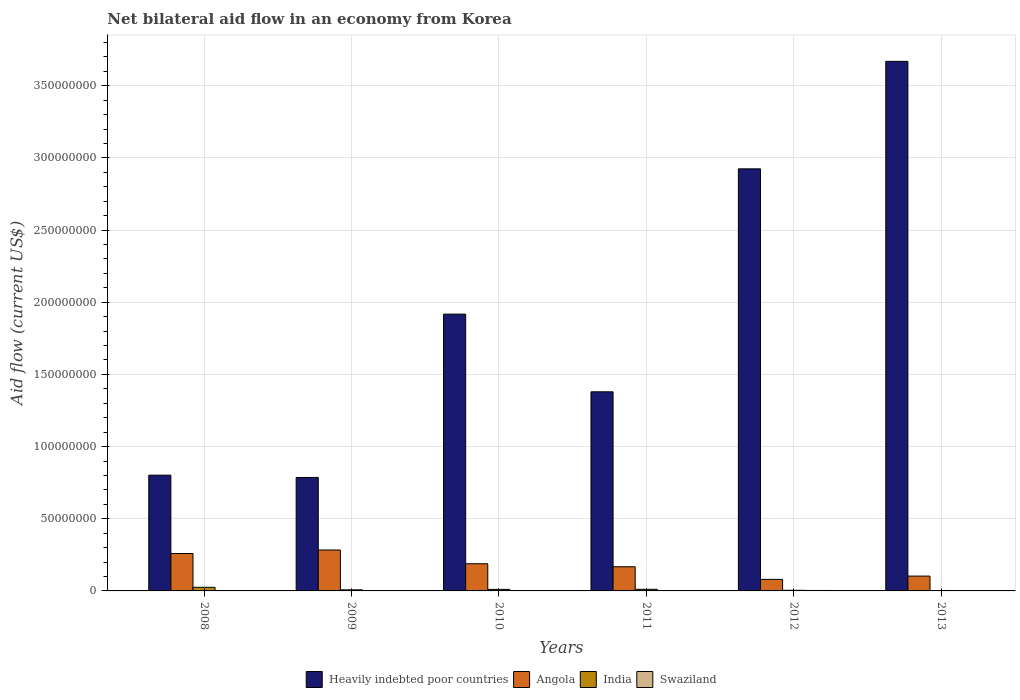Are the number of bars on each tick of the X-axis equal?
Offer a very short reply. Yes. How many bars are there on the 2nd tick from the left?
Make the answer very short. 4. Across all years, what is the maximum net bilateral aid flow in Heavily indebted poor countries?
Keep it short and to the point. 3.67e+08. Across all years, what is the minimum net bilateral aid flow in Heavily indebted poor countries?
Your response must be concise. 7.86e+07. In which year was the net bilateral aid flow in Heavily indebted poor countries maximum?
Your answer should be compact. 2013. What is the total net bilateral aid flow in Swaziland in the graph?
Your answer should be compact. 9.90e+05. What is the difference between the net bilateral aid flow in Angola in 2011 and that in 2013?
Your answer should be compact. 6.47e+06. What is the difference between the net bilateral aid flow in Heavily indebted poor countries in 2009 and the net bilateral aid flow in India in 2012?
Make the answer very short. 7.82e+07. What is the average net bilateral aid flow in Angola per year?
Give a very brief answer. 1.80e+07. In the year 2008, what is the difference between the net bilateral aid flow in Swaziland and net bilateral aid flow in Heavily indebted poor countries?
Your response must be concise. -8.00e+07. In how many years, is the net bilateral aid flow in Heavily indebted poor countries greater than 30000000 US$?
Your response must be concise. 6. What is the ratio of the net bilateral aid flow in Heavily indebted poor countries in 2008 to that in 2009?
Keep it short and to the point. 1.02. Is the difference between the net bilateral aid flow in Swaziland in 2008 and 2009 greater than the difference between the net bilateral aid flow in Heavily indebted poor countries in 2008 and 2009?
Give a very brief answer. No. What is the difference between the highest and the lowest net bilateral aid flow in India?
Ensure brevity in your answer.  2.20e+06. In how many years, is the net bilateral aid flow in Heavily indebted poor countries greater than the average net bilateral aid flow in Heavily indebted poor countries taken over all years?
Your answer should be compact. 3. Is the sum of the net bilateral aid flow in India in 2010 and 2012 greater than the maximum net bilateral aid flow in Swaziland across all years?
Make the answer very short. Yes. What does the 2nd bar from the left in 2008 represents?
Provide a succinct answer. Angola. How many bars are there?
Ensure brevity in your answer.  24. What is the difference between two consecutive major ticks on the Y-axis?
Keep it short and to the point. 5.00e+07. Are the values on the major ticks of Y-axis written in scientific E-notation?
Your answer should be very brief. No. Does the graph contain any zero values?
Offer a terse response. No. Does the graph contain grids?
Your answer should be very brief. Yes. How are the legend labels stacked?
Your answer should be compact. Horizontal. What is the title of the graph?
Make the answer very short. Net bilateral aid flow in an economy from Korea. What is the label or title of the X-axis?
Give a very brief answer. Years. What is the label or title of the Y-axis?
Your answer should be very brief. Aid flow (current US$). What is the Aid flow (current US$) of Heavily indebted poor countries in 2008?
Provide a succinct answer. 8.02e+07. What is the Aid flow (current US$) in Angola in 2008?
Keep it short and to the point. 2.59e+07. What is the Aid flow (current US$) of India in 2008?
Offer a very short reply. 2.50e+06. What is the Aid flow (current US$) of Swaziland in 2008?
Your answer should be very brief. 1.80e+05. What is the Aid flow (current US$) of Heavily indebted poor countries in 2009?
Provide a succinct answer. 7.86e+07. What is the Aid flow (current US$) in Angola in 2009?
Keep it short and to the point. 2.83e+07. What is the Aid flow (current US$) of India in 2009?
Offer a very short reply. 7.50e+05. What is the Aid flow (current US$) in Swaziland in 2009?
Make the answer very short. 1.00e+05. What is the Aid flow (current US$) in Heavily indebted poor countries in 2010?
Your response must be concise. 1.92e+08. What is the Aid flow (current US$) of Angola in 2010?
Your answer should be very brief. 1.88e+07. What is the Aid flow (current US$) in India in 2010?
Provide a succinct answer. 1.07e+06. What is the Aid flow (current US$) in Heavily indebted poor countries in 2011?
Offer a terse response. 1.38e+08. What is the Aid flow (current US$) in Angola in 2011?
Make the answer very short. 1.68e+07. What is the Aid flow (current US$) in India in 2011?
Give a very brief answer. 1.13e+06. What is the Aid flow (current US$) in Swaziland in 2011?
Keep it short and to the point. 1.70e+05. What is the Aid flow (current US$) in Heavily indebted poor countries in 2012?
Offer a very short reply. 2.92e+08. What is the Aid flow (current US$) in Angola in 2012?
Ensure brevity in your answer.  7.98e+06. What is the Aid flow (current US$) of Heavily indebted poor countries in 2013?
Your response must be concise. 3.67e+08. What is the Aid flow (current US$) in Angola in 2013?
Your response must be concise. 1.03e+07. What is the Aid flow (current US$) of India in 2013?
Offer a very short reply. 3.00e+05. Across all years, what is the maximum Aid flow (current US$) in Heavily indebted poor countries?
Your answer should be very brief. 3.67e+08. Across all years, what is the maximum Aid flow (current US$) in Angola?
Your answer should be compact. 2.83e+07. Across all years, what is the maximum Aid flow (current US$) in India?
Provide a succinct answer. 2.50e+06. Across all years, what is the maximum Aid flow (current US$) in Swaziland?
Your answer should be compact. 3.20e+05. Across all years, what is the minimum Aid flow (current US$) in Heavily indebted poor countries?
Your answer should be compact. 7.86e+07. Across all years, what is the minimum Aid flow (current US$) of Angola?
Offer a very short reply. 7.98e+06. Across all years, what is the minimum Aid flow (current US$) of India?
Make the answer very short. 3.00e+05. Across all years, what is the minimum Aid flow (current US$) in Swaziland?
Give a very brief answer. 4.00e+04. What is the total Aid flow (current US$) of Heavily indebted poor countries in the graph?
Your answer should be compact. 1.15e+09. What is the total Aid flow (current US$) of Angola in the graph?
Offer a terse response. 1.08e+08. What is the total Aid flow (current US$) in India in the graph?
Provide a short and direct response. 6.18e+06. What is the total Aid flow (current US$) of Swaziland in the graph?
Offer a very short reply. 9.90e+05. What is the difference between the Aid flow (current US$) of Heavily indebted poor countries in 2008 and that in 2009?
Keep it short and to the point. 1.59e+06. What is the difference between the Aid flow (current US$) of Angola in 2008 and that in 2009?
Offer a very short reply. -2.42e+06. What is the difference between the Aid flow (current US$) in India in 2008 and that in 2009?
Provide a short and direct response. 1.75e+06. What is the difference between the Aid flow (current US$) in Swaziland in 2008 and that in 2009?
Your answer should be very brief. 8.00e+04. What is the difference between the Aid flow (current US$) in Heavily indebted poor countries in 2008 and that in 2010?
Keep it short and to the point. -1.12e+08. What is the difference between the Aid flow (current US$) in Angola in 2008 and that in 2010?
Keep it short and to the point. 7.09e+06. What is the difference between the Aid flow (current US$) of India in 2008 and that in 2010?
Offer a very short reply. 1.43e+06. What is the difference between the Aid flow (current US$) of Swaziland in 2008 and that in 2010?
Your response must be concise. 0. What is the difference between the Aid flow (current US$) of Heavily indebted poor countries in 2008 and that in 2011?
Your answer should be compact. -5.78e+07. What is the difference between the Aid flow (current US$) in Angola in 2008 and that in 2011?
Make the answer very short. 9.17e+06. What is the difference between the Aid flow (current US$) of India in 2008 and that in 2011?
Your response must be concise. 1.37e+06. What is the difference between the Aid flow (current US$) in Swaziland in 2008 and that in 2011?
Offer a very short reply. 10000. What is the difference between the Aid flow (current US$) of Heavily indebted poor countries in 2008 and that in 2012?
Provide a succinct answer. -2.12e+08. What is the difference between the Aid flow (current US$) of Angola in 2008 and that in 2012?
Your answer should be compact. 1.79e+07. What is the difference between the Aid flow (current US$) in India in 2008 and that in 2012?
Give a very brief answer. 2.07e+06. What is the difference between the Aid flow (current US$) of Swaziland in 2008 and that in 2012?
Provide a short and direct response. -1.40e+05. What is the difference between the Aid flow (current US$) in Heavily indebted poor countries in 2008 and that in 2013?
Offer a very short reply. -2.87e+08. What is the difference between the Aid flow (current US$) of Angola in 2008 and that in 2013?
Make the answer very short. 1.56e+07. What is the difference between the Aid flow (current US$) in India in 2008 and that in 2013?
Keep it short and to the point. 2.20e+06. What is the difference between the Aid flow (current US$) of Heavily indebted poor countries in 2009 and that in 2010?
Make the answer very short. -1.13e+08. What is the difference between the Aid flow (current US$) of Angola in 2009 and that in 2010?
Keep it short and to the point. 9.51e+06. What is the difference between the Aid flow (current US$) of India in 2009 and that in 2010?
Provide a succinct answer. -3.20e+05. What is the difference between the Aid flow (current US$) of Heavily indebted poor countries in 2009 and that in 2011?
Your answer should be compact. -5.93e+07. What is the difference between the Aid flow (current US$) of Angola in 2009 and that in 2011?
Offer a very short reply. 1.16e+07. What is the difference between the Aid flow (current US$) in India in 2009 and that in 2011?
Make the answer very short. -3.80e+05. What is the difference between the Aid flow (current US$) in Heavily indebted poor countries in 2009 and that in 2012?
Your answer should be very brief. -2.14e+08. What is the difference between the Aid flow (current US$) in Angola in 2009 and that in 2012?
Keep it short and to the point. 2.04e+07. What is the difference between the Aid flow (current US$) of India in 2009 and that in 2012?
Ensure brevity in your answer.  3.20e+05. What is the difference between the Aid flow (current US$) of Heavily indebted poor countries in 2009 and that in 2013?
Your answer should be compact. -2.88e+08. What is the difference between the Aid flow (current US$) in Angola in 2009 and that in 2013?
Offer a very short reply. 1.81e+07. What is the difference between the Aid flow (current US$) in Swaziland in 2009 and that in 2013?
Ensure brevity in your answer.  6.00e+04. What is the difference between the Aid flow (current US$) in Heavily indebted poor countries in 2010 and that in 2011?
Offer a very short reply. 5.38e+07. What is the difference between the Aid flow (current US$) of Angola in 2010 and that in 2011?
Give a very brief answer. 2.08e+06. What is the difference between the Aid flow (current US$) in India in 2010 and that in 2011?
Make the answer very short. -6.00e+04. What is the difference between the Aid flow (current US$) of Swaziland in 2010 and that in 2011?
Provide a succinct answer. 10000. What is the difference between the Aid flow (current US$) of Heavily indebted poor countries in 2010 and that in 2012?
Ensure brevity in your answer.  -1.01e+08. What is the difference between the Aid flow (current US$) in Angola in 2010 and that in 2012?
Your answer should be compact. 1.08e+07. What is the difference between the Aid flow (current US$) of India in 2010 and that in 2012?
Give a very brief answer. 6.40e+05. What is the difference between the Aid flow (current US$) of Swaziland in 2010 and that in 2012?
Offer a very short reply. -1.40e+05. What is the difference between the Aid flow (current US$) of Heavily indebted poor countries in 2010 and that in 2013?
Your answer should be very brief. -1.75e+08. What is the difference between the Aid flow (current US$) of Angola in 2010 and that in 2013?
Your answer should be very brief. 8.55e+06. What is the difference between the Aid flow (current US$) in India in 2010 and that in 2013?
Provide a short and direct response. 7.70e+05. What is the difference between the Aid flow (current US$) of Swaziland in 2010 and that in 2013?
Offer a terse response. 1.40e+05. What is the difference between the Aid flow (current US$) in Heavily indebted poor countries in 2011 and that in 2012?
Offer a terse response. -1.54e+08. What is the difference between the Aid flow (current US$) in Angola in 2011 and that in 2012?
Your response must be concise. 8.77e+06. What is the difference between the Aid flow (current US$) of Swaziland in 2011 and that in 2012?
Make the answer very short. -1.50e+05. What is the difference between the Aid flow (current US$) of Heavily indebted poor countries in 2011 and that in 2013?
Your answer should be very brief. -2.29e+08. What is the difference between the Aid flow (current US$) of Angola in 2011 and that in 2013?
Offer a terse response. 6.47e+06. What is the difference between the Aid flow (current US$) in India in 2011 and that in 2013?
Offer a terse response. 8.30e+05. What is the difference between the Aid flow (current US$) of Swaziland in 2011 and that in 2013?
Provide a succinct answer. 1.30e+05. What is the difference between the Aid flow (current US$) in Heavily indebted poor countries in 2012 and that in 2013?
Offer a very short reply. -7.45e+07. What is the difference between the Aid flow (current US$) in Angola in 2012 and that in 2013?
Offer a terse response. -2.30e+06. What is the difference between the Aid flow (current US$) of Heavily indebted poor countries in 2008 and the Aid flow (current US$) of Angola in 2009?
Offer a terse response. 5.19e+07. What is the difference between the Aid flow (current US$) of Heavily indebted poor countries in 2008 and the Aid flow (current US$) of India in 2009?
Your answer should be very brief. 7.94e+07. What is the difference between the Aid flow (current US$) in Heavily indebted poor countries in 2008 and the Aid flow (current US$) in Swaziland in 2009?
Your answer should be compact. 8.01e+07. What is the difference between the Aid flow (current US$) of Angola in 2008 and the Aid flow (current US$) of India in 2009?
Offer a very short reply. 2.52e+07. What is the difference between the Aid flow (current US$) of Angola in 2008 and the Aid flow (current US$) of Swaziland in 2009?
Offer a terse response. 2.58e+07. What is the difference between the Aid flow (current US$) in India in 2008 and the Aid flow (current US$) in Swaziland in 2009?
Offer a terse response. 2.40e+06. What is the difference between the Aid flow (current US$) in Heavily indebted poor countries in 2008 and the Aid flow (current US$) in Angola in 2010?
Provide a short and direct response. 6.14e+07. What is the difference between the Aid flow (current US$) in Heavily indebted poor countries in 2008 and the Aid flow (current US$) in India in 2010?
Your answer should be compact. 7.91e+07. What is the difference between the Aid flow (current US$) in Heavily indebted poor countries in 2008 and the Aid flow (current US$) in Swaziland in 2010?
Make the answer very short. 8.00e+07. What is the difference between the Aid flow (current US$) of Angola in 2008 and the Aid flow (current US$) of India in 2010?
Keep it short and to the point. 2.48e+07. What is the difference between the Aid flow (current US$) in Angola in 2008 and the Aid flow (current US$) in Swaziland in 2010?
Offer a terse response. 2.57e+07. What is the difference between the Aid flow (current US$) in India in 2008 and the Aid flow (current US$) in Swaziland in 2010?
Keep it short and to the point. 2.32e+06. What is the difference between the Aid flow (current US$) in Heavily indebted poor countries in 2008 and the Aid flow (current US$) in Angola in 2011?
Offer a very short reply. 6.34e+07. What is the difference between the Aid flow (current US$) of Heavily indebted poor countries in 2008 and the Aid flow (current US$) of India in 2011?
Provide a succinct answer. 7.91e+07. What is the difference between the Aid flow (current US$) in Heavily indebted poor countries in 2008 and the Aid flow (current US$) in Swaziland in 2011?
Your answer should be compact. 8.00e+07. What is the difference between the Aid flow (current US$) in Angola in 2008 and the Aid flow (current US$) in India in 2011?
Your answer should be compact. 2.48e+07. What is the difference between the Aid flow (current US$) in Angola in 2008 and the Aid flow (current US$) in Swaziland in 2011?
Offer a terse response. 2.58e+07. What is the difference between the Aid flow (current US$) in India in 2008 and the Aid flow (current US$) in Swaziland in 2011?
Keep it short and to the point. 2.33e+06. What is the difference between the Aid flow (current US$) of Heavily indebted poor countries in 2008 and the Aid flow (current US$) of Angola in 2012?
Your response must be concise. 7.22e+07. What is the difference between the Aid flow (current US$) of Heavily indebted poor countries in 2008 and the Aid flow (current US$) of India in 2012?
Give a very brief answer. 7.98e+07. What is the difference between the Aid flow (current US$) in Heavily indebted poor countries in 2008 and the Aid flow (current US$) in Swaziland in 2012?
Your answer should be very brief. 7.99e+07. What is the difference between the Aid flow (current US$) in Angola in 2008 and the Aid flow (current US$) in India in 2012?
Make the answer very short. 2.55e+07. What is the difference between the Aid flow (current US$) in Angola in 2008 and the Aid flow (current US$) in Swaziland in 2012?
Offer a very short reply. 2.56e+07. What is the difference between the Aid flow (current US$) in India in 2008 and the Aid flow (current US$) in Swaziland in 2012?
Offer a very short reply. 2.18e+06. What is the difference between the Aid flow (current US$) in Heavily indebted poor countries in 2008 and the Aid flow (current US$) in Angola in 2013?
Ensure brevity in your answer.  6.99e+07. What is the difference between the Aid flow (current US$) of Heavily indebted poor countries in 2008 and the Aid flow (current US$) of India in 2013?
Your answer should be very brief. 7.99e+07. What is the difference between the Aid flow (current US$) of Heavily indebted poor countries in 2008 and the Aid flow (current US$) of Swaziland in 2013?
Your answer should be very brief. 8.02e+07. What is the difference between the Aid flow (current US$) of Angola in 2008 and the Aid flow (current US$) of India in 2013?
Make the answer very short. 2.56e+07. What is the difference between the Aid flow (current US$) of Angola in 2008 and the Aid flow (current US$) of Swaziland in 2013?
Your answer should be very brief. 2.59e+07. What is the difference between the Aid flow (current US$) of India in 2008 and the Aid flow (current US$) of Swaziland in 2013?
Offer a terse response. 2.46e+06. What is the difference between the Aid flow (current US$) in Heavily indebted poor countries in 2009 and the Aid flow (current US$) in Angola in 2010?
Ensure brevity in your answer.  5.98e+07. What is the difference between the Aid flow (current US$) of Heavily indebted poor countries in 2009 and the Aid flow (current US$) of India in 2010?
Provide a succinct answer. 7.75e+07. What is the difference between the Aid flow (current US$) in Heavily indebted poor countries in 2009 and the Aid flow (current US$) in Swaziland in 2010?
Provide a succinct answer. 7.84e+07. What is the difference between the Aid flow (current US$) of Angola in 2009 and the Aid flow (current US$) of India in 2010?
Offer a terse response. 2.73e+07. What is the difference between the Aid flow (current US$) of Angola in 2009 and the Aid flow (current US$) of Swaziland in 2010?
Provide a short and direct response. 2.82e+07. What is the difference between the Aid flow (current US$) of India in 2009 and the Aid flow (current US$) of Swaziland in 2010?
Provide a succinct answer. 5.70e+05. What is the difference between the Aid flow (current US$) of Heavily indebted poor countries in 2009 and the Aid flow (current US$) of Angola in 2011?
Your answer should be very brief. 6.19e+07. What is the difference between the Aid flow (current US$) of Heavily indebted poor countries in 2009 and the Aid flow (current US$) of India in 2011?
Offer a terse response. 7.75e+07. What is the difference between the Aid flow (current US$) in Heavily indebted poor countries in 2009 and the Aid flow (current US$) in Swaziland in 2011?
Your answer should be compact. 7.84e+07. What is the difference between the Aid flow (current US$) of Angola in 2009 and the Aid flow (current US$) of India in 2011?
Offer a terse response. 2.72e+07. What is the difference between the Aid flow (current US$) of Angola in 2009 and the Aid flow (current US$) of Swaziland in 2011?
Your answer should be very brief. 2.82e+07. What is the difference between the Aid flow (current US$) in India in 2009 and the Aid flow (current US$) in Swaziland in 2011?
Provide a succinct answer. 5.80e+05. What is the difference between the Aid flow (current US$) in Heavily indebted poor countries in 2009 and the Aid flow (current US$) in Angola in 2012?
Your answer should be compact. 7.06e+07. What is the difference between the Aid flow (current US$) in Heavily indebted poor countries in 2009 and the Aid flow (current US$) in India in 2012?
Provide a short and direct response. 7.82e+07. What is the difference between the Aid flow (current US$) of Heavily indebted poor countries in 2009 and the Aid flow (current US$) of Swaziland in 2012?
Your answer should be very brief. 7.83e+07. What is the difference between the Aid flow (current US$) in Angola in 2009 and the Aid flow (current US$) in India in 2012?
Provide a short and direct response. 2.79e+07. What is the difference between the Aid flow (current US$) in Angola in 2009 and the Aid flow (current US$) in Swaziland in 2012?
Give a very brief answer. 2.80e+07. What is the difference between the Aid flow (current US$) of Heavily indebted poor countries in 2009 and the Aid flow (current US$) of Angola in 2013?
Offer a very short reply. 6.83e+07. What is the difference between the Aid flow (current US$) of Heavily indebted poor countries in 2009 and the Aid flow (current US$) of India in 2013?
Your response must be concise. 7.83e+07. What is the difference between the Aid flow (current US$) of Heavily indebted poor countries in 2009 and the Aid flow (current US$) of Swaziland in 2013?
Your answer should be very brief. 7.86e+07. What is the difference between the Aid flow (current US$) in Angola in 2009 and the Aid flow (current US$) in India in 2013?
Make the answer very short. 2.80e+07. What is the difference between the Aid flow (current US$) in Angola in 2009 and the Aid flow (current US$) in Swaziland in 2013?
Your answer should be compact. 2.83e+07. What is the difference between the Aid flow (current US$) in India in 2009 and the Aid flow (current US$) in Swaziland in 2013?
Keep it short and to the point. 7.10e+05. What is the difference between the Aid flow (current US$) of Heavily indebted poor countries in 2010 and the Aid flow (current US$) of Angola in 2011?
Offer a very short reply. 1.75e+08. What is the difference between the Aid flow (current US$) of Heavily indebted poor countries in 2010 and the Aid flow (current US$) of India in 2011?
Ensure brevity in your answer.  1.91e+08. What is the difference between the Aid flow (current US$) in Heavily indebted poor countries in 2010 and the Aid flow (current US$) in Swaziland in 2011?
Keep it short and to the point. 1.92e+08. What is the difference between the Aid flow (current US$) in Angola in 2010 and the Aid flow (current US$) in India in 2011?
Provide a succinct answer. 1.77e+07. What is the difference between the Aid flow (current US$) in Angola in 2010 and the Aid flow (current US$) in Swaziland in 2011?
Your answer should be compact. 1.87e+07. What is the difference between the Aid flow (current US$) in Heavily indebted poor countries in 2010 and the Aid flow (current US$) in Angola in 2012?
Your answer should be compact. 1.84e+08. What is the difference between the Aid flow (current US$) of Heavily indebted poor countries in 2010 and the Aid flow (current US$) of India in 2012?
Ensure brevity in your answer.  1.91e+08. What is the difference between the Aid flow (current US$) of Heavily indebted poor countries in 2010 and the Aid flow (current US$) of Swaziland in 2012?
Make the answer very short. 1.91e+08. What is the difference between the Aid flow (current US$) in Angola in 2010 and the Aid flow (current US$) in India in 2012?
Your answer should be compact. 1.84e+07. What is the difference between the Aid flow (current US$) in Angola in 2010 and the Aid flow (current US$) in Swaziland in 2012?
Keep it short and to the point. 1.85e+07. What is the difference between the Aid flow (current US$) in India in 2010 and the Aid flow (current US$) in Swaziland in 2012?
Keep it short and to the point. 7.50e+05. What is the difference between the Aid flow (current US$) of Heavily indebted poor countries in 2010 and the Aid flow (current US$) of Angola in 2013?
Offer a terse response. 1.81e+08. What is the difference between the Aid flow (current US$) of Heavily indebted poor countries in 2010 and the Aid flow (current US$) of India in 2013?
Offer a terse response. 1.91e+08. What is the difference between the Aid flow (current US$) in Heavily indebted poor countries in 2010 and the Aid flow (current US$) in Swaziland in 2013?
Your answer should be compact. 1.92e+08. What is the difference between the Aid flow (current US$) of Angola in 2010 and the Aid flow (current US$) of India in 2013?
Offer a very short reply. 1.85e+07. What is the difference between the Aid flow (current US$) of Angola in 2010 and the Aid flow (current US$) of Swaziland in 2013?
Make the answer very short. 1.88e+07. What is the difference between the Aid flow (current US$) in India in 2010 and the Aid flow (current US$) in Swaziland in 2013?
Keep it short and to the point. 1.03e+06. What is the difference between the Aid flow (current US$) in Heavily indebted poor countries in 2011 and the Aid flow (current US$) in Angola in 2012?
Provide a short and direct response. 1.30e+08. What is the difference between the Aid flow (current US$) in Heavily indebted poor countries in 2011 and the Aid flow (current US$) in India in 2012?
Offer a very short reply. 1.38e+08. What is the difference between the Aid flow (current US$) in Heavily indebted poor countries in 2011 and the Aid flow (current US$) in Swaziland in 2012?
Make the answer very short. 1.38e+08. What is the difference between the Aid flow (current US$) in Angola in 2011 and the Aid flow (current US$) in India in 2012?
Your answer should be compact. 1.63e+07. What is the difference between the Aid flow (current US$) in Angola in 2011 and the Aid flow (current US$) in Swaziland in 2012?
Offer a very short reply. 1.64e+07. What is the difference between the Aid flow (current US$) in India in 2011 and the Aid flow (current US$) in Swaziland in 2012?
Give a very brief answer. 8.10e+05. What is the difference between the Aid flow (current US$) in Heavily indebted poor countries in 2011 and the Aid flow (current US$) in Angola in 2013?
Provide a short and direct response. 1.28e+08. What is the difference between the Aid flow (current US$) in Heavily indebted poor countries in 2011 and the Aid flow (current US$) in India in 2013?
Offer a terse response. 1.38e+08. What is the difference between the Aid flow (current US$) in Heavily indebted poor countries in 2011 and the Aid flow (current US$) in Swaziland in 2013?
Make the answer very short. 1.38e+08. What is the difference between the Aid flow (current US$) in Angola in 2011 and the Aid flow (current US$) in India in 2013?
Give a very brief answer. 1.64e+07. What is the difference between the Aid flow (current US$) of Angola in 2011 and the Aid flow (current US$) of Swaziland in 2013?
Your response must be concise. 1.67e+07. What is the difference between the Aid flow (current US$) of India in 2011 and the Aid flow (current US$) of Swaziland in 2013?
Ensure brevity in your answer.  1.09e+06. What is the difference between the Aid flow (current US$) of Heavily indebted poor countries in 2012 and the Aid flow (current US$) of Angola in 2013?
Offer a terse response. 2.82e+08. What is the difference between the Aid flow (current US$) of Heavily indebted poor countries in 2012 and the Aid flow (current US$) of India in 2013?
Keep it short and to the point. 2.92e+08. What is the difference between the Aid flow (current US$) of Heavily indebted poor countries in 2012 and the Aid flow (current US$) of Swaziland in 2013?
Offer a terse response. 2.92e+08. What is the difference between the Aid flow (current US$) in Angola in 2012 and the Aid flow (current US$) in India in 2013?
Your answer should be compact. 7.68e+06. What is the difference between the Aid flow (current US$) in Angola in 2012 and the Aid flow (current US$) in Swaziland in 2013?
Your answer should be very brief. 7.94e+06. What is the difference between the Aid flow (current US$) in India in 2012 and the Aid flow (current US$) in Swaziland in 2013?
Give a very brief answer. 3.90e+05. What is the average Aid flow (current US$) of Heavily indebted poor countries per year?
Your answer should be compact. 1.91e+08. What is the average Aid flow (current US$) in Angola per year?
Offer a very short reply. 1.80e+07. What is the average Aid flow (current US$) of India per year?
Offer a terse response. 1.03e+06. What is the average Aid flow (current US$) in Swaziland per year?
Your answer should be very brief. 1.65e+05. In the year 2008, what is the difference between the Aid flow (current US$) in Heavily indebted poor countries and Aid flow (current US$) in Angola?
Your answer should be very brief. 5.43e+07. In the year 2008, what is the difference between the Aid flow (current US$) in Heavily indebted poor countries and Aid flow (current US$) in India?
Provide a short and direct response. 7.77e+07. In the year 2008, what is the difference between the Aid flow (current US$) of Heavily indebted poor countries and Aid flow (current US$) of Swaziland?
Make the answer very short. 8.00e+07. In the year 2008, what is the difference between the Aid flow (current US$) in Angola and Aid flow (current US$) in India?
Your answer should be compact. 2.34e+07. In the year 2008, what is the difference between the Aid flow (current US$) of Angola and Aid flow (current US$) of Swaziland?
Provide a succinct answer. 2.57e+07. In the year 2008, what is the difference between the Aid flow (current US$) in India and Aid flow (current US$) in Swaziland?
Your answer should be very brief. 2.32e+06. In the year 2009, what is the difference between the Aid flow (current US$) of Heavily indebted poor countries and Aid flow (current US$) of Angola?
Ensure brevity in your answer.  5.03e+07. In the year 2009, what is the difference between the Aid flow (current US$) in Heavily indebted poor countries and Aid flow (current US$) in India?
Offer a very short reply. 7.79e+07. In the year 2009, what is the difference between the Aid flow (current US$) in Heavily indebted poor countries and Aid flow (current US$) in Swaziland?
Provide a succinct answer. 7.85e+07. In the year 2009, what is the difference between the Aid flow (current US$) of Angola and Aid flow (current US$) of India?
Your response must be concise. 2.76e+07. In the year 2009, what is the difference between the Aid flow (current US$) in Angola and Aid flow (current US$) in Swaziland?
Make the answer very short. 2.82e+07. In the year 2009, what is the difference between the Aid flow (current US$) in India and Aid flow (current US$) in Swaziland?
Provide a short and direct response. 6.50e+05. In the year 2010, what is the difference between the Aid flow (current US$) of Heavily indebted poor countries and Aid flow (current US$) of Angola?
Provide a short and direct response. 1.73e+08. In the year 2010, what is the difference between the Aid flow (current US$) of Heavily indebted poor countries and Aid flow (current US$) of India?
Provide a succinct answer. 1.91e+08. In the year 2010, what is the difference between the Aid flow (current US$) in Heavily indebted poor countries and Aid flow (current US$) in Swaziland?
Offer a very short reply. 1.92e+08. In the year 2010, what is the difference between the Aid flow (current US$) of Angola and Aid flow (current US$) of India?
Offer a very short reply. 1.78e+07. In the year 2010, what is the difference between the Aid flow (current US$) of Angola and Aid flow (current US$) of Swaziland?
Offer a very short reply. 1.86e+07. In the year 2010, what is the difference between the Aid flow (current US$) in India and Aid flow (current US$) in Swaziland?
Your answer should be very brief. 8.90e+05. In the year 2011, what is the difference between the Aid flow (current US$) in Heavily indebted poor countries and Aid flow (current US$) in Angola?
Keep it short and to the point. 1.21e+08. In the year 2011, what is the difference between the Aid flow (current US$) in Heavily indebted poor countries and Aid flow (current US$) in India?
Your answer should be very brief. 1.37e+08. In the year 2011, what is the difference between the Aid flow (current US$) in Heavily indebted poor countries and Aid flow (current US$) in Swaziland?
Make the answer very short. 1.38e+08. In the year 2011, what is the difference between the Aid flow (current US$) of Angola and Aid flow (current US$) of India?
Your answer should be compact. 1.56e+07. In the year 2011, what is the difference between the Aid flow (current US$) of Angola and Aid flow (current US$) of Swaziland?
Provide a succinct answer. 1.66e+07. In the year 2011, what is the difference between the Aid flow (current US$) in India and Aid flow (current US$) in Swaziland?
Offer a terse response. 9.60e+05. In the year 2012, what is the difference between the Aid flow (current US$) in Heavily indebted poor countries and Aid flow (current US$) in Angola?
Keep it short and to the point. 2.84e+08. In the year 2012, what is the difference between the Aid flow (current US$) of Heavily indebted poor countries and Aid flow (current US$) of India?
Your response must be concise. 2.92e+08. In the year 2012, what is the difference between the Aid flow (current US$) in Heavily indebted poor countries and Aid flow (current US$) in Swaziland?
Give a very brief answer. 2.92e+08. In the year 2012, what is the difference between the Aid flow (current US$) in Angola and Aid flow (current US$) in India?
Your answer should be compact. 7.55e+06. In the year 2012, what is the difference between the Aid flow (current US$) in Angola and Aid flow (current US$) in Swaziland?
Your answer should be compact. 7.66e+06. In the year 2013, what is the difference between the Aid flow (current US$) of Heavily indebted poor countries and Aid flow (current US$) of Angola?
Give a very brief answer. 3.57e+08. In the year 2013, what is the difference between the Aid flow (current US$) in Heavily indebted poor countries and Aid flow (current US$) in India?
Your response must be concise. 3.67e+08. In the year 2013, what is the difference between the Aid flow (current US$) in Heavily indebted poor countries and Aid flow (current US$) in Swaziland?
Your answer should be very brief. 3.67e+08. In the year 2013, what is the difference between the Aid flow (current US$) in Angola and Aid flow (current US$) in India?
Keep it short and to the point. 9.98e+06. In the year 2013, what is the difference between the Aid flow (current US$) in Angola and Aid flow (current US$) in Swaziland?
Keep it short and to the point. 1.02e+07. What is the ratio of the Aid flow (current US$) in Heavily indebted poor countries in 2008 to that in 2009?
Provide a short and direct response. 1.02. What is the ratio of the Aid flow (current US$) in Angola in 2008 to that in 2009?
Offer a terse response. 0.91. What is the ratio of the Aid flow (current US$) in Swaziland in 2008 to that in 2009?
Provide a succinct answer. 1.8. What is the ratio of the Aid flow (current US$) in Heavily indebted poor countries in 2008 to that in 2010?
Provide a short and direct response. 0.42. What is the ratio of the Aid flow (current US$) in Angola in 2008 to that in 2010?
Offer a terse response. 1.38. What is the ratio of the Aid flow (current US$) in India in 2008 to that in 2010?
Provide a succinct answer. 2.34. What is the ratio of the Aid flow (current US$) in Heavily indebted poor countries in 2008 to that in 2011?
Ensure brevity in your answer.  0.58. What is the ratio of the Aid flow (current US$) in Angola in 2008 to that in 2011?
Make the answer very short. 1.55. What is the ratio of the Aid flow (current US$) of India in 2008 to that in 2011?
Your answer should be very brief. 2.21. What is the ratio of the Aid flow (current US$) in Swaziland in 2008 to that in 2011?
Offer a very short reply. 1.06. What is the ratio of the Aid flow (current US$) of Heavily indebted poor countries in 2008 to that in 2012?
Provide a short and direct response. 0.27. What is the ratio of the Aid flow (current US$) of Angola in 2008 to that in 2012?
Give a very brief answer. 3.25. What is the ratio of the Aid flow (current US$) in India in 2008 to that in 2012?
Your response must be concise. 5.81. What is the ratio of the Aid flow (current US$) of Swaziland in 2008 to that in 2012?
Make the answer very short. 0.56. What is the ratio of the Aid flow (current US$) in Heavily indebted poor countries in 2008 to that in 2013?
Keep it short and to the point. 0.22. What is the ratio of the Aid flow (current US$) in Angola in 2008 to that in 2013?
Provide a succinct answer. 2.52. What is the ratio of the Aid flow (current US$) in India in 2008 to that in 2013?
Make the answer very short. 8.33. What is the ratio of the Aid flow (current US$) in Heavily indebted poor countries in 2009 to that in 2010?
Give a very brief answer. 0.41. What is the ratio of the Aid flow (current US$) of Angola in 2009 to that in 2010?
Provide a succinct answer. 1.5. What is the ratio of the Aid flow (current US$) in India in 2009 to that in 2010?
Provide a short and direct response. 0.7. What is the ratio of the Aid flow (current US$) in Swaziland in 2009 to that in 2010?
Your answer should be very brief. 0.56. What is the ratio of the Aid flow (current US$) of Heavily indebted poor countries in 2009 to that in 2011?
Your answer should be compact. 0.57. What is the ratio of the Aid flow (current US$) in Angola in 2009 to that in 2011?
Your answer should be very brief. 1.69. What is the ratio of the Aid flow (current US$) in India in 2009 to that in 2011?
Give a very brief answer. 0.66. What is the ratio of the Aid flow (current US$) in Swaziland in 2009 to that in 2011?
Offer a very short reply. 0.59. What is the ratio of the Aid flow (current US$) in Heavily indebted poor countries in 2009 to that in 2012?
Offer a very short reply. 0.27. What is the ratio of the Aid flow (current US$) in Angola in 2009 to that in 2012?
Your answer should be compact. 3.55. What is the ratio of the Aid flow (current US$) of India in 2009 to that in 2012?
Offer a very short reply. 1.74. What is the ratio of the Aid flow (current US$) in Swaziland in 2009 to that in 2012?
Offer a terse response. 0.31. What is the ratio of the Aid flow (current US$) of Heavily indebted poor countries in 2009 to that in 2013?
Offer a terse response. 0.21. What is the ratio of the Aid flow (current US$) in Angola in 2009 to that in 2013?
Your response must be concise. 2.76. What is the ratio of the Aid flow (current US$) in Swaziland in 2009 to that in 2013?
Keep it short and to the point. 2.5. What is the ratio of the Aid flow (current US$) in Heavily indebted poor countries in 2010 to that in 2011?
Your response must be concise. 1.39. What is the ratio of the Aid flow (current US$) in Angola in 2010 to that in 2011?
Ensure brevity in your answer.  1.12. What is the ratio of the Aid flow (current US$) of India in 2010 to that in 2011?
Your answer should be compact. 0.95. What is the ratio of the Aid flow (current US$) of Swaziland in 2010 to that in 2011?
Provide a succinct answer. 1.06. What is the ratio of the Aid flow (current US$) of Heavily indebted poor countries in 2010 to that in 2012?
Give a very brief answer. 0.66. What is the ratio of the Aid flow (current US$) in Angola in 2010 to that in 2012?
Provide a short and direct response. 2.36. What is the ratio of the Aid flow (current US$) in India in 2010 to that in 2012?
Provide a short and direct response. 2.49. What is the ratio of the Aid flow (current US$) of Swaziland in 2010 to that in 2012?
Make the answer very short. 0.56. What is the ratio of the Aid flow (current US$) in Heavily indebted poor countries in 2010 to that in 2013?
Make the answer very short. 0.52. What is the ratio of the Aid flow (current US$) in Angola in 2010 to that in 2013?
Keep it short and to the point. 1.83. What is the ratio of the Aid flow (current US$) in India in 2010 to that in 2013?
Give a very brief answer. 3.57. What is the ratio of the Aid flow (current US$) of Swaziland in 2010 to that in 2013?
Give a very brief answer. 4.5. What is the ratio of the Aid flow (current US$) in Heavily indebted poor countries in 2011 to that in 2012?
Offer a terse response. 0.47. What is the ratio of the Aid flow (current US$) in Angola in 2011 to that in 2012?
Offer a terse response. 2.1. What is the ratio of the Aid flow (current US$) of India in 2011 to that in 2012?
Keep it short and to the point. 2.63. What is the ratio of the Aid flow (current US$) of Swaziland in 2011 to that in 2012?
Offer a very short reply. 0.53. What is the ratio of the Aid flow (current US$) of Heavily indebted poor countries in 2011 to that in 2013?
Your response must be concise. 0.38. What is the ratio of the Aid flow (current US$) of Angola in 2011 to that in 2013?
Give a very brief answer. 1.63. What is the ratio of the Aid flow (current US$) in India in 2011 to that in 2013?
Your answer should be compact. 3.77. What is the ratio of the Aid flow (current US$) of Swaziland in 2011 to that in 2013?
Your answer should be very brief. 4.25. What is the ratio of the Aid flow (current US$) in Heavily indebted poor countries in 2012 to that in 2013?
Make the answer very short. 0.8. What is the ratio of the Aid flow (current US$) of Angola in 2012 to that in 2013?
Provide a succinct answer. 0.78. What is the ratio of the Aid flow (current US$) of India in 2012 to that in 2013?
Offer a very short reply. 1.43. What is the ratio of the Aid flow (current US$) of Swaziland in 2012 to that in 2013?
Your response must be concise. 8. What is the difference between the highest and the second highest Aid flow (current US$) in Heavily indebted poor countries?
Offer a very short reply. 7.45e+07. What is the difference between the highest and the second highest Aid flow (current US$) in Angola?
Your response must be concise. 2.42e+06. What is the difference between the highest and the second highest Aid flow (current US$) in India?
Provide a succinct answer. 1.37e+06. What is the difference between the highest and the lowest Aid flow (current US$) in Heavily indebted poor countries?
Give a very brief answer. 2.88e+08. What is the difference between the highest and the lowest Aid flow (current US$) in Angola?
Provide a short and direct response. 2.04e+07. What is the difference between the highest and the lowest Aid flow (current US$) in India?
Offer a very short reply. 2.20e+06. What is the difference between the highest and the lowest Aid flow (current US$) of Swaziland?
Make the answer very short. 2.80e+05. 